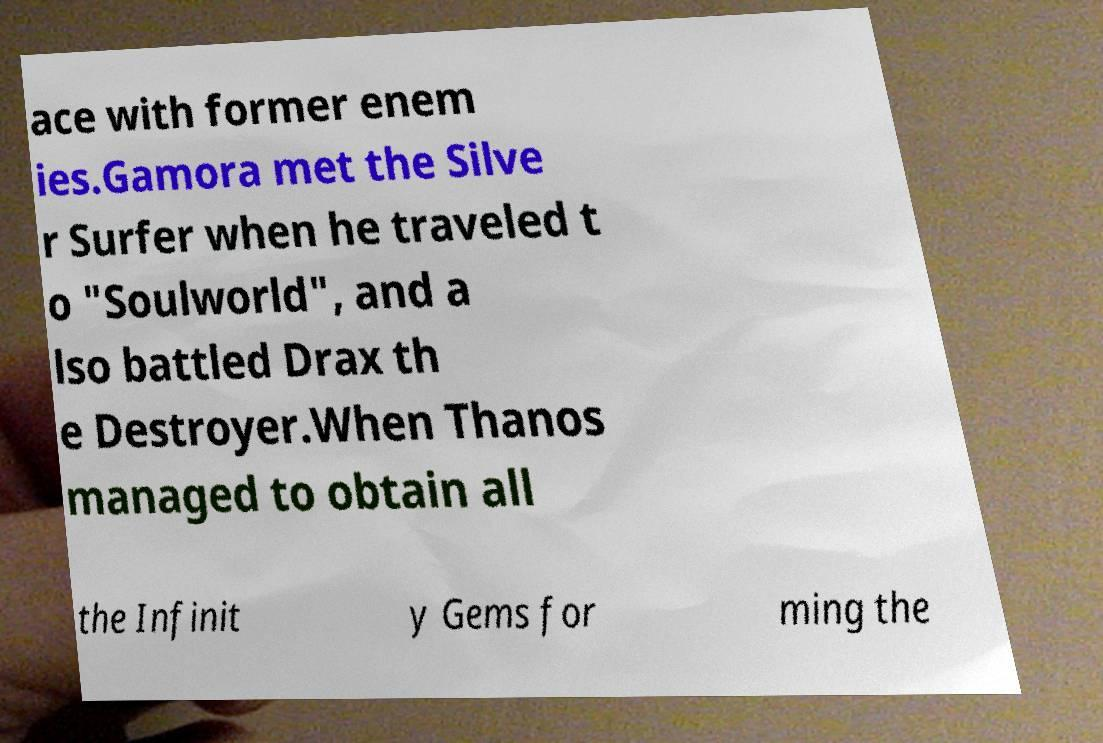Can you read and provide the text displayed in the image?This photo seems to have some interesting text. Can you extract and type it out for me? ace with former enem ies.Gamora met the Silve r Surfer when he traveled t o "Soulworld", and a lso battled Drax th e Destroyer.When Thanos managed to obtain all the Infinit y Gems for ming the 